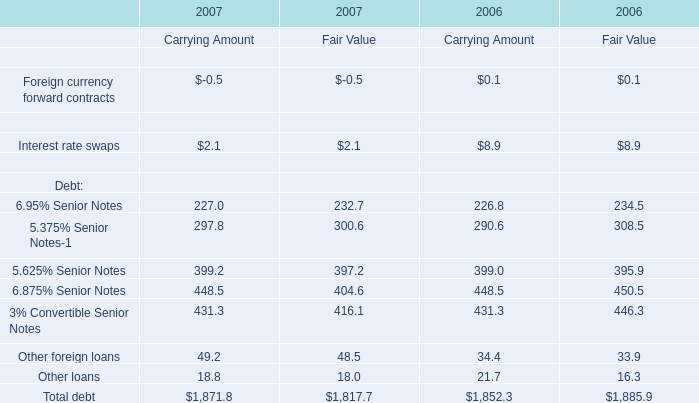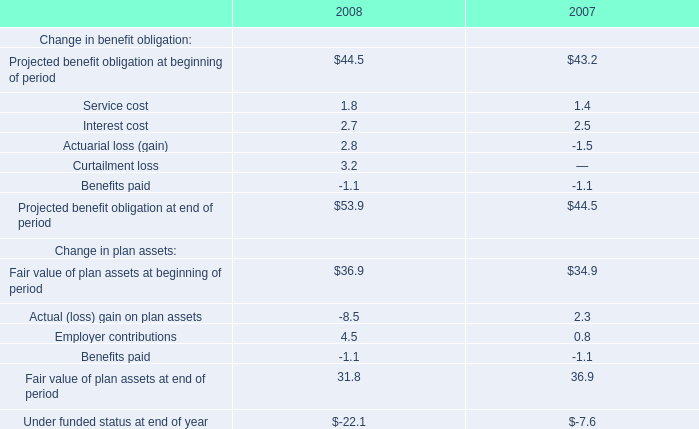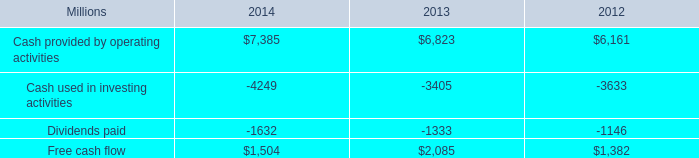what was the percentage change in free cash flow from 2013 to 2014? 
Computations: ((1504 - 2085) / 2085)
Answer: -0.27866. 